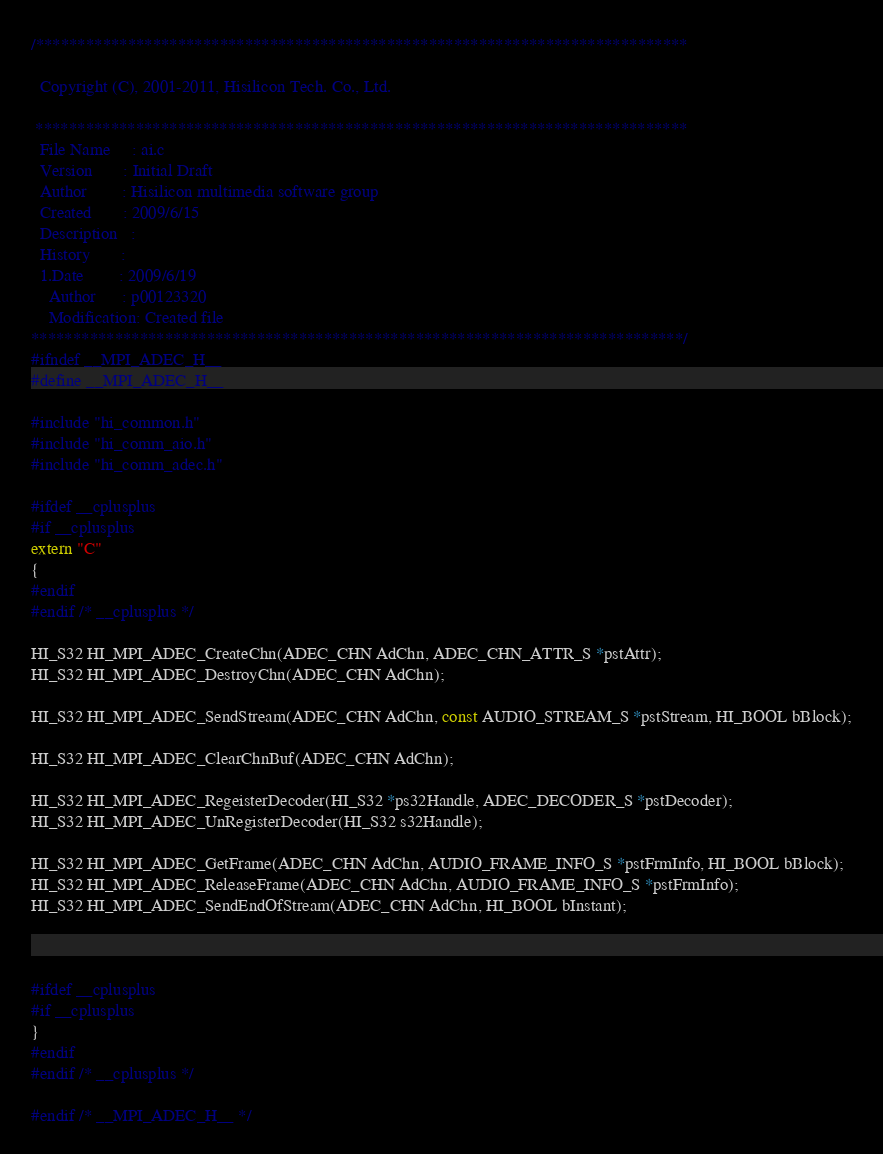Convert code to text. <code><loc_0><loc_0><loc_500><loc_500><_C_>/******************************************************************************

  Copyright (C), 2001-2011, Hisilicon Tech. Co., Ltd.

 ******************************************************************************
  File Name     : ai.c
  Version       : Initial Draft
  Author        : Hisilicon multimedia software group
  Created       : 2009/6/15
  Description   : 
  History       :
  1.Date        : 2009/6/19
    Author      : p00123320
    Modification: Created file    
******************************************************************************/
#ifndef __MPI_ADEC_H__
#define __MPI_ADEC_H__

#include "hi_common.h"
#include "hi_comm_aio.h"
#include "hi_comm_adec.h"

#ifdef __cplusplus
#if __cplusplus
extern "C"
{
#endif
#endif /* __cplusplus */

HI_S32 HI_MPI_ADEC_CreateChn(ADEC_CHN AdChn, ADEC_CHN_ATTR_S *pstAttr);
HI_S32 HI_MPI_ADEC_DestroyChn(ADEC_CHN AdChn);

HI_S32 HI_MPI_ADEC_SendStream(ADEC_CHN AdChn, const AUDIO_STREAM_S *pstStream, HI_BOOL bBlock);

HI_S32 HI_MPI_ADEC_ClearChnBuf(ADEC_CHN AdChn);

HI_S32 HI_MPI_ADEC_RegeisterDecoder(HI_S32 *ps32Handle, ADEC_DECODER_S *pstDecoder);
HI_S32 HI_MPI_ADEC_UnRegisterDecoder(HI_S32 s32Handle);

HI_S32 HI_MPI_ADEC_GetFrame(ADEC_CHN AdChn, AUDIO_FRAME_INFO_S *pstFrmInfo, HI_BOOL bBlock);
HI_S32 HI_MPI_ADEC_ReleaseFrame(ADEC_CHN AdChn, AUDIO_FRAME_INFO_S *pstFrmInfo);
HI_S32 HI_MPI_ADEC_SendEndOfStream(ADEC_CHN AdChn, HI_BOOL bInstant);



#ifdef __cplusplus
#if __cplusplus
}
#endif
#endif /* __cplusplus */

#endif /* __MPI_ADEC_H__ */

</code> 